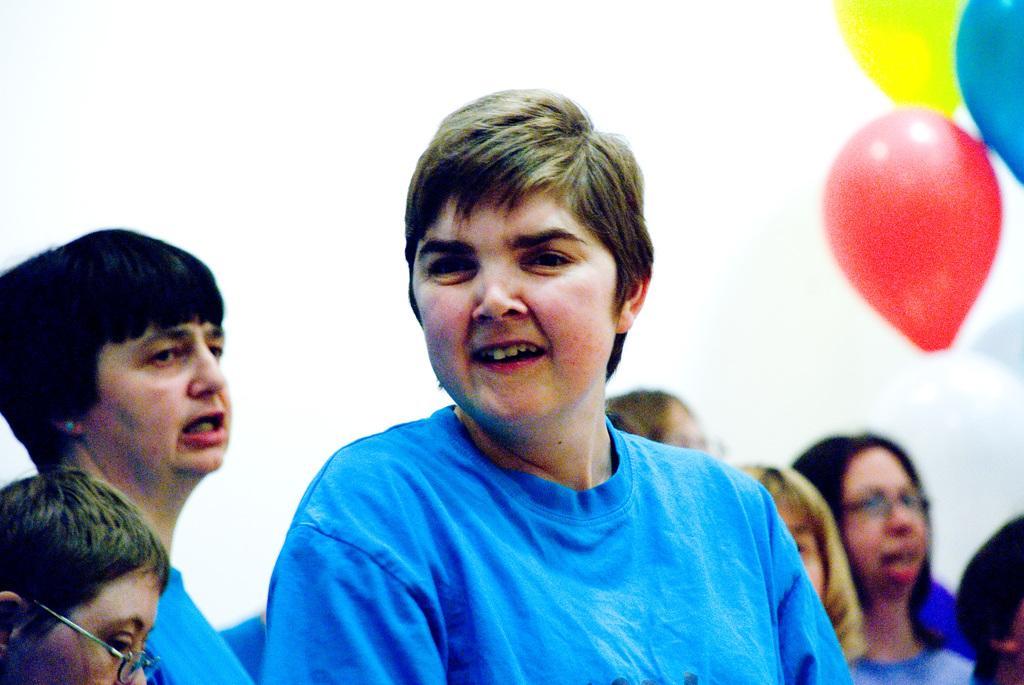Please provide a concise description of this image. In this image we can see persons, wall and balloons. 